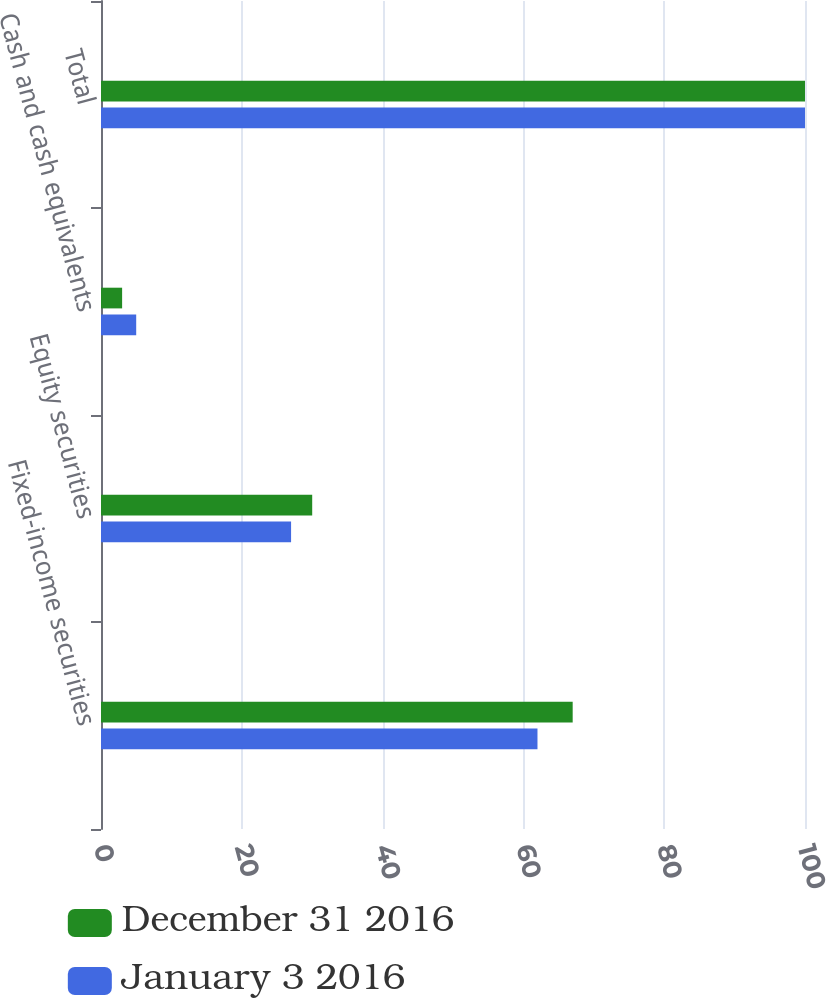<chart> <loc_0><loc_0><loc_500><loc_500><stacked_bar_chart><ecel><fcel>Fixed-income securities<fcel>Equity securities<fcel>Cash and cash equivalents<fcel>Total<nl><fcel>December 31 2016<fcel>67<fcel>30<fcel>3<fcel>100<nl><fcel>January 3 2016<fcel>62<fcel>27<fcel>5<fcel>100<nl></chart> 